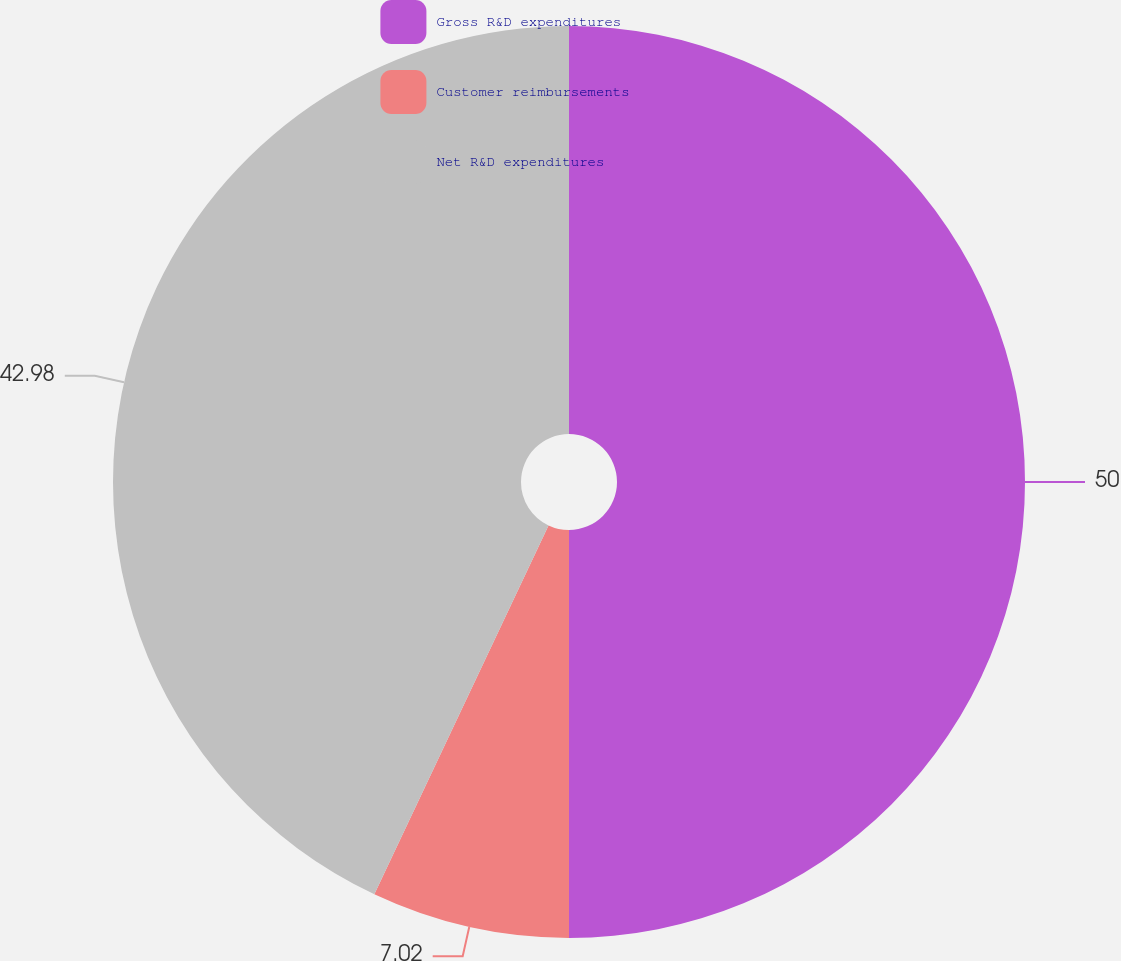Convert chart. <chart><loc_0><loc_0><loc_500><loc_500><pie_chart><fcel>Gross R&D expenditures<fcel>Customer reimbursements<fcel>Net R&D expenditures<nl><fcel>50.0%<fcel>7.02%<fcel>42.98%<nl></chart> 